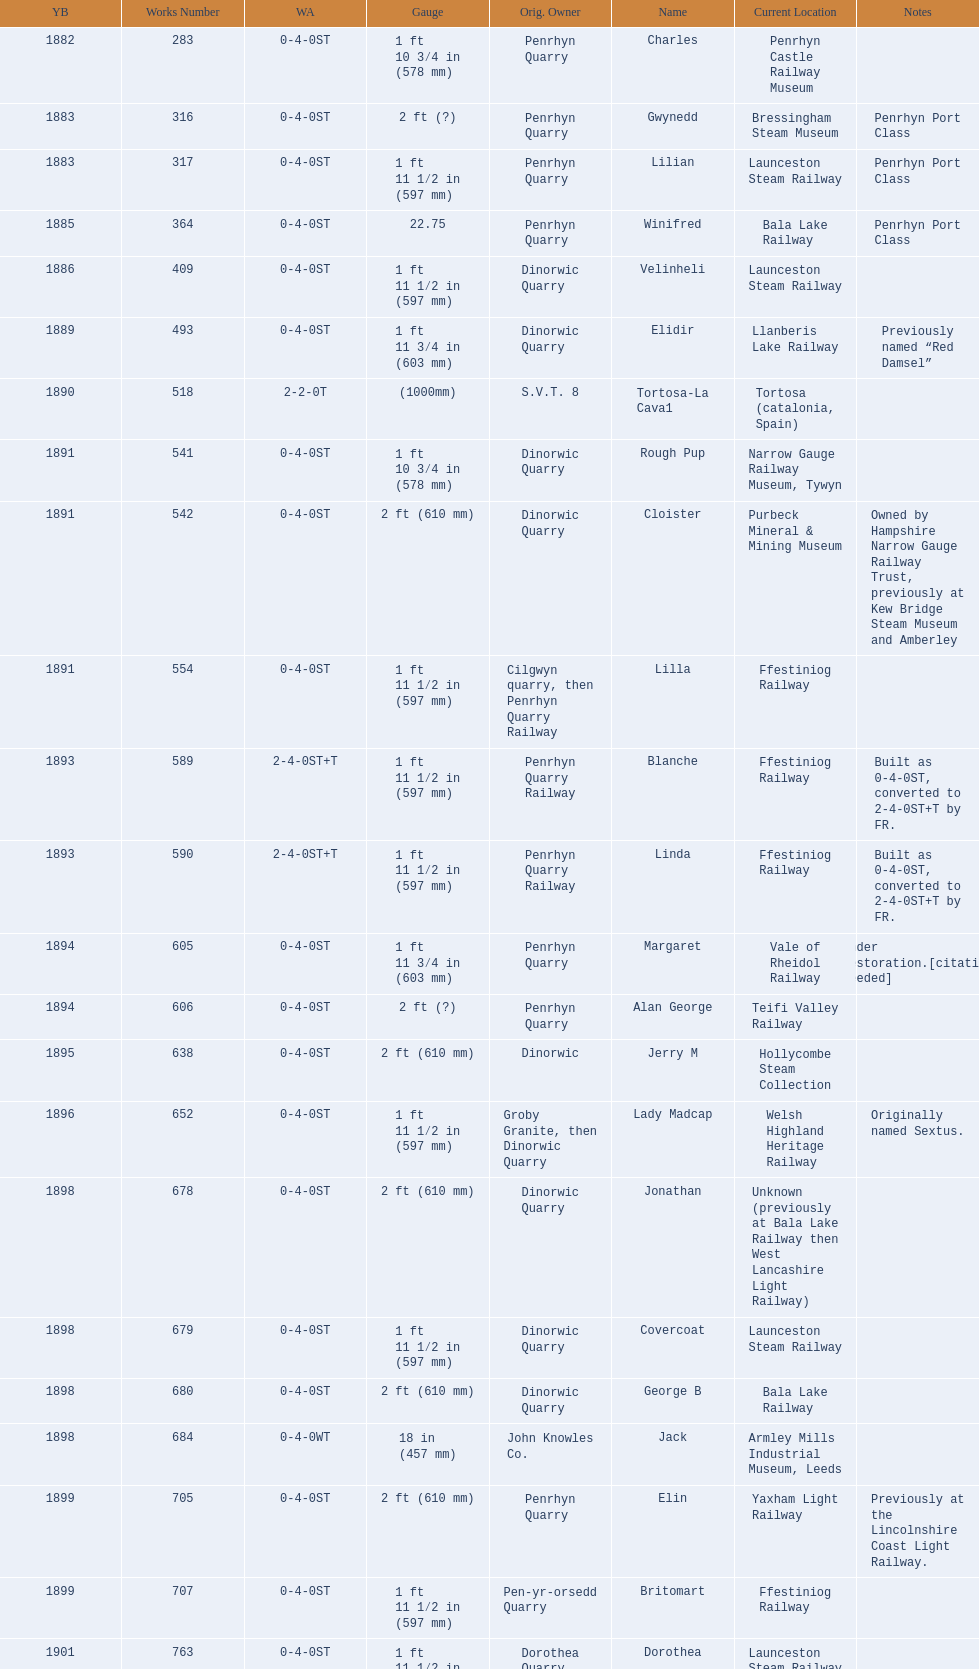Could you parse the entire table? {'header': ['YB', 'Works Number', 'WA', 'Gauge', 'Orig. Owner', 'Name', 'Current Location', 'Notes'], 'rows': [['1882', '283', '0-4-0ST', '1\xa0ft 10\xa03⁄4\xa0in (578\xa0mm)', 'Penrhyn Quarry', 'Charles', 'Penrhyn Castle Railway Museum', ''], ['1883', '316', '0-4-0ST', '2\xa0ft (?)', 'Penrhyn Quarry', 'Gwynedd', 'Bressingham Steam Museum', 'Penrhyn Port Class'], ['1883', '317', '0-4-0ST', '1\xa0ft 11\xa01⁄2\xa0in (597\xa0mm)', 'Penrhyn Quarry', 'Lilian', 'Launceston Steam Railway', 'Penrhyn Port Class'], ['1885', '364', '0-4-0ST', '22.75', 'Penrhyn Quarry', 'Winifred', 'Bala Lake Railway', 'Penrhyn Port Class'], ['1886', '409', '0-4-0ST', '1\xa0ft 11\xa01⁄2\xa0in (597\xa0mm)', 'Dinorwic Quarry', 'Velinheli', 'Launceston Steam Railway', ''], ['1889', '493', '0-4-0ST', '1\xa0ft 11\xa03⁄4\xa0in (603\xa0mm)', 'Dinorwic Quarry', 'Elidir', 'Llanberis Lake Railway', 'Previously named “Red Damsel”'], ['1890', '518', '2-2-0T', '(1000mm)', 'S.V.T. 8', 'Tortosa-La Cava1', 'Tortosa (catalonia, Spain)', ''], ['1891', '541', '0-4-0ST', '1\xa0ft 10\xa03⁄4\xa0in (578\xa0mm)', 'Dinorwic Quarry', 'Rough Pup', 'Narrow Gauge Railway Museum, Tywyn', ''], ['1891', '542', '0-4-0ST', '2\xa0ft (610\xa0mm)', 'Dinorwic Quarry', 'Cloister', 'Purbeck Mineral & Mining Museum', 'Owned by Hampshire Narrow Gauge Railway Trust, previously at Kew Bridge Steam Museum and Amberley'], ['1891', '554', '0-4-0ST', '1\xa0ft 11\xa01⁄2\xa0in (597\xa0mm)', 'Cilgwyn quarry, then Penrhyn Quarry Railway', 'Lilla', 'Ffestiniog Railway', ''], ['1893', '589', '2-4-0ST+T', '1\xa0ft 11\xa01⁄2\xa0in (597\xa0mm)', 'Penrhyn Quarry Railway', 'Blanche', 'Ffestiniog Railway', 'Built as 0-4-0ST, converted to 2-4-0ST+T by FR.'], ['1893', '590', '2-4-0ST+T', '1\xa0ft 11\xa01⁄2\xa0in (597\xa0mm)', 'Penrhyn Quarry Railway', 'Linda', 'Ffestiniog Railway', 'Built as 0-4-0ST, converted to 2-4-0ST+T by FR.'], ['1894', '605', '0-4-0ST', '1\xa0ft 11\xa03⁄4\xa0in (603\xa0mm)', 'Penrhyn Quarry', 'Margaret', 'Vale of Rheidol Railway', 'Under restoration.[citation needed]'], ['1894', '606', '0-4-0ST', '2\xa0ft (?)', 'Penrhyn Quarry', 'Alan George', 'Teifi Valley Railway', ''], ['1895', '638', '0-4-0ST', '2\xa0ft (610\xa0mm)', 'Dinorwic', 'Jerry M', 'Hollycombe Steam Collection', ''], ['1896', '652', '0-4-0ST', '1\xa0ft 11\xa01⁄2\xa0in (597\xa0mm)', 'Groby Granite, then Dinorwic Quarry', 'Lady Madcap', 'Welsh Highland Heritage Railway', 'Originally named Sextus.'], ['1898', '678', '0-4-0ST', '2\xa0ft (610\xa0mm)', 'Dinorwic Quarry', 'Jonathan', 'Unknown (previously at Bala Lake Railway then West Lancashire Light Railway)', ''], ['1898', '679', '0-4-0ST', '1\xa0ft 11\xa01⁄2\xa0in (597\xa0mm)', 'Dinorwic Quarry', 'Covercoat', 'Launceston Steam Railway', ''], ['1898', '680', '0-4-0ST', '2\xa0ft (610\xa0mm)', 'Dinorwic Quarry', 'George B', 'Bala Lake Railway', ''], ['1898', '684', '0-4-0WT', '18\xa0in (457\xa0mm)', 'John Knowles Co.', 'Jack', 'Armley Mills Industrial Museum, Leeds', ''], ['1899', '705', '0-4-0ST', '2\xa0ft (610\xa0mm)', 'Penrhyn Quarry', 'Elin', 'Yaxham Light Railway', 'Previously at the Lincolnshire Coast Light Railway.'], ['1899', '707', '0-4-0ST', '1\xa0ft 11\xa01⁄2\xa0in (597\xa0mm)', 'Pen-yr-orsedd Quarry', 'Britomart', 'Ffestiniog Railway', ''], ['1901', '763', '0-4-0ST', '1\xa0ft 11\xa01⁄2\xa0in (597\xa0mm)', 'Dorothea Quarry', 'Dorothea', 'Launceston Steam Railway', ''], ['1902', '779', '0-4-0ST', '2\xa0ft (610\xa0mm)', 'Dinorwic Quarry', 'Holy War', 'Bala Lake Railway', ''], ['1902', '780', '0-4-0ST', '2\xa0ft (610\xa0mm)', 'Dinorwic Quarry', 'Alice', 'Bala Lake Railway', ''], ['1902', '783', '0-6-0T', '(1000mm)', 'Sociedad General de Ferrocarriles Vasco-Asturiana', 'VA-21 Nalon', 'Gijon Railway Museum (Spain)', ''], ['1903', '822', '0-4-0ST', '2\xa0ft (610\xa0mm)', 'Dinorwic Quarry', 'Maid Marian', 'Bala Lake Railway', ''], ['1903', '823', '0-4-0ST', '2\xa0ft (?)', 'Dinorwic Quarry', 'Irish Mail', 'West Lancashire Light Railway', ''], ['1903', '827', '0-4-0ST', '1\xa0ft 11\xa03⁄4\xa0in (603\xa0mm)', 'Pen-yr-orsedd Quarry', 'Sybil', 'Brecon Mountain Railway', ''], ['1904', '855', '0-4-0ST', '1\xa0ft 10\xa03⁄4\xa0in (578\xa0mm)', 'Penryn Quarry', 'Hugh Napier', 'Penrhyn Castle Railway Museum, Gwynedd', ''], ['1905', '873', '0-4-0ST', '2\xa0ft (?)', 'Pen-yr-orsedd Quarry', 'Una', 'National Slate Museum, Llanberis', ''], ['1904', '894', '0-4-0ST', '1\xa0ft 11\xa03⁄4\xa0in (603\xa0mm)', 'Dinorwic Quarry', 'Thomas Bach', 'Llanberis Lake Railway', 'Originally named “Wild Aster”'], ['1906', '901', '2-6-2T', '1\xa0ft 11\xa01⁄2\xa0in (597\xa0mm)', 'North Wales Narrow Gauge Railways', 'Russell', 'Welsh Highland Heritage Railway', ''], ['1906', '920', '0-4-0ST', '2\xa0ft (?)', 'Penrhyn Quarry', 'Pamela', 'Old Kiln Light Railway', ''], ['1909', '994', '0-4-0ST', '2\xa0ft (?)', 'Penrhyn Quarry', 'Bill Harvey', 'Bressingham Steam Museum', 'previously George Sholto'], ['1918', '1312', '4-6-0T', '1\xa0ft\xa011\xa01⁄2\xa0in (597\xa0mm)', 'British War Department\\nEFOP #203', '---', 'Pampas Safari, Gravataí, RS, Brazil', '[citation needed]'], ['1918\\nor\\n1921?', '1313', '0-6-2T', '3\xa0ft\xa03\xa03⁄8\xa0in (1,000\xa0mm)', 'British War Department\\nUsina Leão Utinga #1\\nUsina Laginha #1', '---', 'Usina Laginha, União dos Palmares, AL, Brazil', '[citation needed]'], ['1920', '1404', '0-4-0WT', '18\xa0in (457\xa0mm)', 'John Knowles Co.', 'Gwen', 'Richard Farmer current owner, Northridge, California, USA', ''], ['1922', '1429', '0-4-0ST', '2\xa0ft (610\xa0mm)', 'Dinorwic', 'Lady Joan', 'Bredgar and Wormshill Light Railway', ''], ['1922', '1430', '0-4-0ST', '1\xa0ft 11\xa03⁄4\xa0in (603\xa0mm)', 'Dinorwic Quarry', 'Dolbadarn', 'Llanberis Lake Railway', ''], ['1937', '1859', '0-4-2T', '2\xa0ft (?)', 'Umtwalumi Valley Estate, Natal', '16 Carlisle', 'South Tynedale Railway', ''], ['1940', '2075', '0-4-2T', '2\xa0ft (?)', 'Chaka’s Kraal Sugar Estates, Natal', 'Chaka’s Kraal No. 6', 'North Gloucestershire Railway', ''], ['1954', '3815', '2-6-2T', '2\xa0ft 6\xa0in (762\xa0mm)', 'Sierra Leone Government Railway', '14', 'Welshpool and Llanfair Light Railway', ''], ['1971', '3902', '0-4-2ST', '2\xa0ft (610\xa0mm)', 'Trangkil Sugar Mill, Indonesia', 'Trangkil No.4', 'Statfold Barn Railway', 'Converted from 750\xa0mm (2\xa0ft\xa05\xa01⁄2\xa0in) gauge. Last steam locomotive to be built by Hunslet, and the last industrial steam locomotive built in Britain.']]} How many steam locomotives are currently located at the bala lake railway? 364. 